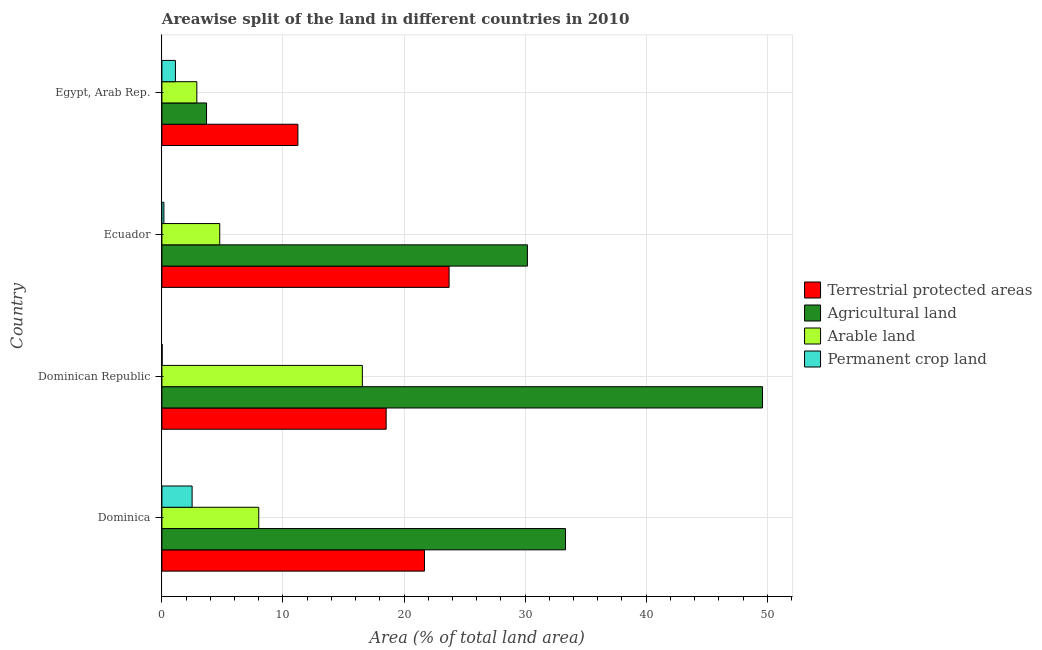Are the number of bars per tick equal to the number of legend labels?
Offer a very short reply. Yes. Are the number of bars on each tick of the Y-axis equal?
Provide a short and direct response. Yes. How many bars are there on the 1st tick from the bottom?
Your answer should be very brief. 4. What is the label of the 3rd group of bars from the top?
Provide a succinct answer. Dominican Republic. What is the percentage of area under agricultural land in Egypt, Arab Rep.?
Your answer should be very brief. 3.69. Across all countries, what is the maximum percentage of area under permanent crop land?
Give a very brief answer. 2.5. Across all countries, what is the minimum percentage of area under agricultural land?
Provide a succinct answer. 3.69. In which country was the percentage of land under terrestrial protection maximum?
Your answer should be very brief. Ecuador. In which country was the percentage of area under permanent crop land minimum?
Provide a short and direct response. Dominican Republic. What is the total percentage of area under agricultural land in the graph?
Provide a short and direct response. 116.82. What is the difference between the percentage of area under permanent crop land in Dominica and that in Egypt, Arab Rep.?
Your answer should be compact. 1.38. What is the difference between the percentage of area under permanent crop land in Dominican Republic and the percentage of area under agricultural land in Egypt, Arab Rep.?
Give a very brief answer. -3.67. What is the average percentage of area under arable land per country?
Give a very brief answer. 8.05. What is the difference between the percentage of land under terrestrial protection and percentage of area under agricultural land in Dominican Republic?
Your answer should be compact. -31.08. In how many countries, is the percentage of area under agricultural land greater than 42 %?
Offer a very short reply. 1. What is the ratio of the percentage of land under terrestrial protection in Dominica to that in Dominican Republic?
Keep it short and to the point. 1.17. Is the difference between the percentage of area under permanent crop land in Dominica and Ecuador greater than the difference between the percentage of area under agricultural land in Dominica and Ecuador?
Ensure brevity in your answer.  No. What is the difference between the highest and the second highest percentage of area under agricultural land?
Provide a short and direct response. 16.27. What is the difference between the highest and the lowest percentage of area under arable land?
Provide a succinct answer. 13.67. Is the sum of the percentage of area under permanent crop land in Dominican Republic and Egypt, Arab Rep. greater than the maximum percentage of area under agricultural land across all countries?
Offer a very short reply. No. What does the 3rd bar from the top in Dominica represents?
Offer a very short reply. Agricultural land. What does the 1st bar from the bottom in Egypt, Arab Rep. represents?
Your response must be concise. Terrestrial protected areas. Are all the bars in the graph horizontal?
Make the answer very short. Yes. Does the graph contain any zero values?
Keep it short and to the point. No. Where does the legend appear in the graph?
Make the answer very short. Center right. How many legend labels are there?
Your response must be concise. 4. What is the title of the graph?
Ensure brevity in your answer.  Areawise split of the land in different countries in 2010. What is the label or title of the X-axis?
Provide a succinct answer. Area (% of total land area). What is the Area (% of total land area) in Terrestrial protected areas in Dominica?
Keep it short and to the point. 21.69. What is the Area (% of total land area) in Agricultural land in Dominica?
Ensure brevity in your answer.  33.33. What is the Area (% of total land area) in Permanent crop land in Dominica?
Provide a short and direct response. 2.5. What is the Area (% of total land area) in Terrestrial protected areas in Dominican Republic?
Make the answer very short. 18.52. What is the Area (% of total land area) of Agricultural land in Dominican Republic?
Your answer should be compact. 49.61. What is the Area (% of total land area) in Arable land in Dominican Republic?
Offer a very short reply. 16.56. What is the Area (% of total land area) of Permanent crop land in Dominican Republic?
Offer a terse response. 0.02. What is the Area (% of total land area) in Terrestrial protected areas in Ecuador?
Ensure brevity in your answer.  23.72. What is the Area (% of total land area) of Agricultural land in Ecuador?
Your answer should be very brief. 30.19. What is the Area (% of total land area) in Arable land in Ecuador?
Your answer should be compact. 4.78. What is the Area (% of total land area) in Permanent crop land in Ecuador?
Your answer should be very brief. 0.17. What is the Area (% of total land area) in Terrestrial protected areas in Egypt, Arab Rep.?
Provide a short and direct response. 11.23. What is the Area (% of total land area) in Agricultural land in Egypt, Arab Rep.?
Your response must be concise. 3.69. What is the Area (% of total land area) in Arable land in Egypt, Arab Rep.?
Your response must be concise. 2.89. What is the Area (% of total land area) of Permanent crop land in Egypt, Arab Rep.?
Provide a short and direct response. 1.12. Across all countries, what is the maximum Area (% of total land area) in Terrestrial protected areas?
Offer a very short reply. 23.72. Across all countries, what is the maximum Area (% of total land area) of Agricultural land?
Your response must be concise. 49.61. Across all countries, what is the maximum Area (% of total land area) of Arable land?
Keep it short and to the point. 16.56. Across all countries, what is the maximum Area (% of total land area) of Permanent crop land?
Your response must be concise. 2.5. Across all countries, what is the minimum Area (% of total land area) of Terrestrial protected areas?
Give a very brief answer. 11.23. Across all countries, what is the minimum Area (% of total land area) in Agricultural land?
Keep it short and to the point. 3.69. Across all countries, what is the minimum Area (% of total land area) in Arable land?
Keep it short and to the point. 2.89. Across all countries, what is the minimum Area (% of total land area) in Permanent crop land?
Your answer should be very brief. 0.02. What is the total Area (% of total land area) of Terrestrial protected areas in the graph?
Your answer should be compact. 75.16. What is the total Area (% of total land area) of Agricultural land in the graph?
Your answer should be compact. 116.82. What is the total Area (% of total land area) of Arable land in the graph?
Your answer should be compact. 32.22. What is the total Area (% of total land area) in Permanent crop land in the graph?
Your answer should be compact. 3.8. What is the difference between the Area (% of total land area) in Terrestrial protected areas in Dominica and that in Dominican Republic?
Make the answer very short. 3.16. What is the difference between the Area (% of total land area) of Agricultural land in Dominica and that in Dominican Republic?
Offer a very short reply. -16.27. What is the difference between the Area (% of total land area) of Arable land in Dominica and that in Dominican Republic?
Ensure brevity in your answer.  -8.56. What is the difference between the Area (% of total land area) of Permanent crop land in Dominica and that in Dominican Republic?
Provide a succinct answer. 2.48. What is the difference between the Area (% of total land area) of Terrestrial protected areas in Dominica and that in Ecuador?
Your answer should be very brief. -2.03. What is the difference between the Area (% of total land area) of Agricultural land in Dominica and that in Ecuador?
Your response must be concise. 3.14. What is the difference between the Area (% of total land area) of Arable land in Dominica and that in Ecuador?
Provide a succinct answer. 3.22. What is the difference between the Area (% of total land area) of Permanent crop land in Dominica and that in Ecuador?
Offer a terse response. 2.33. What is the difference between the Area (% of total land area) in Terrestrial protected areas in Dominica and that in Egypt, Arab Rep.?
Ensure brevity in your answer.  10.46. What is the difference between the Area (% of total land area) of Agricultural land in Dominica and that in Egypt, Arab Rep.?
Your answer should be very brief. 29.65. What is the difference between the Area (% of total land area) of Arable land in Dominica and that in Egypt, Arab Rep.?
Make the answer very short. 5.11. What is the difference between the Area (% of total land area) of Permanent crop land in Dominica and that in Egypt, Arab Rep.?
Keep it short and to the point. 1.38. What is the difference between the Area (% of total land area) in Terrestrial protected areas in Dominican Republic and that in Ecuador?
Keep it short and to the point. -5.2. What is the difference between the Area (% of total land area) in Agricultural land in Dominican Republic and that in Ecuador?
Provide a short and direct response. 19.42. What is the difference between the Area (% of total land area) of Arable land in Dominican Republic and that in Ecuador?
Ensure brevity in your answer.  11.78. What is the difference between the Area (% of total land area) of Permanent crop land in Dominican Republic and that in Ecuador?
Offer a terse response. -0.15. What is the difference between the Area (% of total land area) of Terrestrial protected areas in Dominican Republic and that in Egypt, Arab Rep.?
Keep it short and to the point. 7.29. What is the difference between the Area (% of total land area) in Agricultural land in Dominican Republic and that in Egypt, Arab Rep.?
Make the answer very short. 45.92. What is the difference between the Area (% of total land area) of Arable land in Dominican Republic and that in Egypt, Arab Rep.?
Offer a very short reply. 13.67. What is the difference between the Area (% of total land area) of Permanent crop land in Dominican Republic and that in Egypt, Arab Rep.?
Provide a succinct answer. -1.1. What is the difference between the Area (% of total land area) of Terrestrial protected areas in Ecuador and that in Egypt, Arab Rep.?
Provide a short and direct response. 12.49. What is the difference between the Area (% of total land area) of Agricultural land in Ecuador and that in Egypt, Arab Rep.?
Your answer should be compact. 26.5. What is the difference between the Area (% of total land area) in Arable land in Ecuador and that in Egypt, Arab Rep.?
Your response must be concise. 1.89. What is the difference between the Area (% of total land area) in Permanent crop land in Ecuador and that in Egypt, Arab Rep.?
Offer a very short reply. -0.95. What is the difference between the Area (% of total land area) in Terrestrial protected areas in Dominica and the Area (% of total land area) in Agricultural land in Dominican Republic?
Your response must be concise. -27.92. What is the difference between the Area (% of total land area) in Terrestrial protected areas in Dominica and the Area (% of total land area) in Arable land in Dominican Republic?
Provide a short and direct response. 5.13. What is the difference between the Area (% of total land area) in Terrestrial protected areas in Dominica and the Area (% of total land area) in Permanent crop land in Dominican Republic?
Your answer should be very brief. 21.67. What is the difference between the Area (% of total land area) of Agricultural land in Dominica and the Area (% of total land area) of Arable land in Dominican Republic?
Make the answer very short. 16.78. What is the difference between the Area (% of total land area) of Agricultural land in Dominica and the Area (% of total land area) of Permanent crop land in Dominican Republic?
Offer a very short reply. 33.31. What is the difference between the Area (% of total land area) of Arable land in Dominica and the Area (% of total land area) of Permanent crop land in Dominican Republic?
Provide a succinct answer. 7.98. What is the difference between the Area (% of total land area) in Terrestrial protected areas in Dominica and the Area (% of total land area) in Agricultural land in Ecuador?
Make the answer very short. -8.5. What is the difference between the Area (% of total land area) of Terrestrial protected areas in Dominica and the Area (% of total land area) of Arable land in Ecuador?
Ensure brevity in your answer.  16.91. What is the difference between the Area (% of total land area) in Terrestrial protected areas in Dominica and the Area (% of total land area) in Permanent crop land in Ecuador?
Provide a short and direct response. 21.52. What is the difference between the Area (% of total land area) of Agricultural land in Dominica and the Area (% of total land area) of Arable land in Ecuador?
Your answer should be very brief. 28.56. What is the difference between the Area (% of total land area) in Agricultural land in Dominica and the Area (% of total land area) in Permanent crop land in Ecuador?
Offer a very short reply. 33.17. What is the difference between the Area (% of total land area) of Arable land in Dominica and the Area (% of total land area) of Permanent crop land in Ecuador?
Ensure brevity in your answer.  7.83. What is the difference between the Area (% of total land area) in Terrestrial protected areas in Dominica and the Area (% of total land area) in Agricultural land in Egypt, Arab Rep.?
Provide a short and direct response. 18. What is the difference between the Area (% of total land area) of Terrestrial protected areas in Dominica and the Area (% of total land area) of Arable land in Egypt, Arab Rep.?
Provide a short and direct response. 18.8. What is the difference between the Area (% of total land area) in Terrestrial protected areas in Dominica and the Area (% of total land area) in Permanent crop land in Egypt, Arab Rep.?
Ensure brevity in your answer.  20.57. What is the difference between the Area (% of total land area) in Agricultural land in Dominica and the Area (% of total land area) in Arable land in Egypt, Arab Rep.?
Your answer should be compact. 30.45. What is the difference between the Area (% of total land area) in Agricultural land in Dominica and the Area (% of total land area) in Permanent crop land in Egypt, Arab Rep.?
Give a very brief answer. 32.22. What is the difference between the Area (% of total land area) of Arable land in Dominica and the Area (% of total land area) of Permanent crop land in Egypt, Arab Rep.?
Keep it short and to the point. 6.88. What is the difference between the Area (% of total land area) of Terrestrial protected areas in Dominican Republic and the Area (% of total land area) of Agricultural land in Ecuador?
Give a very brief answer. -11.67. What is the difference between the Area (% of total land area) in Terrestrial protected areas in Dominican Republic and the Area (% of total land area) in Arable land in Ecuador?
Make the answer very short. 13.75. What is the difference between the Area (% of total land area) of Terrestrial protected areas in Dominican Republic and the Area (% of total land area) of Permanent crop land in Ecuador?
Your response must be concise. 18.36. What is the difference between the Area (% of total land area) in Agricultural land in Dominican Republic and the Area (% of total land area) in Arable land in Ecuador?
Your answer should be compact. 44.83. What is the difference between the Area (% of total land area) of Agricultural land in Dominican Republic and the Area (% of total land area) of Permanent crop land in Ecuador?
Keep it short and to the point. 49.44. What is the difference between the Area (% of total land area) in Arable land in Dominican Republic and the Area (% of total land area) in Permanent crop land in Ecuador?
Provide a succinct answer. 16.39. What is the difference between the Area (% of total land area) of Terrestrial protected areas in Dominican Republic and the Area (% of total land area) of Agricultural land in Egypt, Arab Rep.?
Offer a very short reply. 14.84. What is the difference between the Area (% of total land area) in Terrestrial protected areas in Dominican Republic and the Area (% of total land area) in Arable land in Egypt, Arab Rep.?
Your response must be concise. 15.64. What is the difference between the Area (% of total land area) in Terrestrial protected areas in Dominican Republic and the Area (% of total land area) in Permanent crop land in Egypt, Arab Rep.?
Your answer should be very brief. 17.4. What is the difference between the Area (% of total land area) of Agricultural land in Dominican Republic and the Area (% of total land area) of Arable land in Egypt, Arab Rep.?
Provide a short and direct response. 46.72. What is the difference between the Area (% of total land area) in Agricultural land in Dominican Republic and the Area (% of total land area) in Permanent crop land in Egypt, Arab Rep.?
Make the answer very short. 48.49. What is the difference between the Area (% of total land area) of Arable land in Dominican Republic and the Area (% of total land area) of Permanent crop land in Egypt, Arab Rep.?
Provide a short and direct response. 15.44. What is the difference between the Area (% of total land area) in Terrestrial protected areas in Ecuador and the Area (% of total land area) in Agricultural land in Egypt, Arab Rep.?
Your answer should be very brief. 20.03. What is the difference between the Area (% of total land area) in Terrestrial protected areas in Ecuador and the Area (% of total land area) in Arable land in Egypt, Arab Rep.?
Keep it short and to the point. 20.83. What is the difference between the Area (% of total land area) of Terrestrial protected areas in Ecuador and the Area (% of total land area) of Permanent crop land in Egypt, Arab Rep.?
Offer a very short reply. 22.6. What is the difference between the Area (% of total land area) in Agricultural land in Ecuador and the Area (% of total land area) in Arable land in Egypt, Arab Rep.?
Provide a short and direct response. 27.3. What is the difference between the Area (% of total land area) in Agricultural land in Ecuador and the Area (% of total land area) in Permanent crop land in Egypt, Arab Rep.?
Ensure brevity in your answer.  29.07. What is the difference between the Area (% of total land area) in Arable land in Ecuador and the Area (% of total land area) in Permanent crop land in Egypt, Arab Rep.?
Offer a terse response. 3.66. What is the average Area (% of total land area) in Terrestrial protected areas per country?
Offer a terse response. 18.79. What is the average Area (% of total land area) of Agricultural land per country?
Offer a terse response. 29.2. What is the average Area (% of total land area) of Arable land per country?
Make the answer very short. 8.05. What is the average Area (% of total land area) in Permanent crop land per country?
Make the answer very short. 0.95. What is the difference between the Area (% of total land area) in Terrestrial protected areas and Area (% of total land area) in Agricultural land in Dominica?
Offer a very short reply. -11.65. What is the difference between the Area (% of total land area) in Terrestrial protected areas and Area (% of total land area) in Arable land in Dominica?
Your answer should be very brief. 13.69. What is the difference between the Area (% of total land area) in Terrestrial protected areas and Area (% of total land area) in Permanent crop land in Dominica?
Offer a terse response. 19.19. What is the difference between the Area (% of total land area) in Agricultural land and Area (% of total land area) in Arable land in Dominica?
Provide a short and direct response. 25.33. What is the difference between the Area (% of total land area) of Agricultural land and Area (% of total land area) of Permanent crop land in Dominica?
Offer a terse response. 30.84. What is the difference between the Area (% of total land area) of Arable land and Area (% of total land area) of Permanent crop land in Dominica?
Make the answer very short. 5.5. What is the difference between the Area (% of total land area) of Terrestrial protected areas and Area (% of total land area) of Agricultural land in Dominican Republic?
Offer a very short reply. -31.08. What is the difference between the Area (% of total land area) in Terrestrial protected areas and Area (% of total land area) in Arable land in Dominican Republic?
Your answer should be compact. 1.97. What is the difference between the Area (% of total land area) of Terrestrial protected areas and Area (% of total land area) of Permanent crop land in Dominican Republic?
Your answer should be compact. 18.5. What is the difference between the Area (% of total land area) of Agricultural land and Area (% of total land area) of Arable land in Dominican Republic?
Offer a very short reply. 33.05. What is the difference between the Area (% of total land area) of Agricultural land and Area (% of total land area) of Permanent crop land in Dominican Republic?
Offer a very short reply. 49.59. What is the difference between the Area (% of total land area) of Arable land and Area (% of total land area) of Permanent crop land in Dominican Republic?
Your answer should be compact. 16.54. What is the difference between the Area (% of total land area) of Terrestrial protected areas and Area (% of total land area) of Agricultural land in Ecuador?
Offer a terse response. -6.47. What is the difference between the Area (% of total land area) of Terrestrial protected areas and Area (% of total land area) of Arable land in Ecuador?
Provide a succinct answer. 18.94. What is the difference between the Area (% of total land area) of Terrestrial protected areas and Area (% of total land area) of Permanent crop land in Ecuador?
Keep it short and to the point. 23.56. What is the difference between the Area (% of total land area) in Agricultural land and Area (% of total land area) in Arable land in Ecuador?
Keep it short and to the point. 25.41. What is the difference between the Area (% of total land area) in Agricultural land and Area (% of total land area) in Permanent crop land in Ecuador?
Provide a short and direct response. 30.02. What is the difference between the Area (% of total land area) of Arable land and Area (% of total land area) of Permanent crop land in Ecuador?
Provide a succinct answer. 4.61. What is the difference between the Area (% of total land area) in Terrestrial protected areas and Area (% of total land area) in Agricultural land in Egypt, Arab Rep.?
Provide a short and direct response. 7.54. What is the difference between the Area (% of total land area) in Terrestrial protected areas and Area (% of total land area) in Arable land in Egypt, Arab Rep.?
Offer a very short reply. 8.35. What is the difference between the Area (% of total land area) of Terrestrial protected areas and Area (% of total land area) of Permanent crop land in Egypt, Arab Rep.?
Make the answer very short. 10.11. What is the difference between the Area (% of total land area) of Agricultural land and Area (% of total land area) of Arable land in Egypt, Arab Rep.?
Your answer should be very brief. 0.8. What is the difference between the Area (% of total land area) in Agricultural land and Area (% of total land area) in Permanent crop land in Egypt, Arab Rep.?
Provide a short and direct response. 2.57. What is the difference between the Area (% of total land area) of Arable land and Area (% of total land area) of Permanent crop land in Egypt, Arab Rep.?
Provide a short and direct response. 1.77. What is the ratio of the Area (% of total land area) of Terrestrial protected areas in Dominica to that in Dominican Republic?
Your response must be concise. 1.17. What is the ratio of the Area (% of total land area) of Agricultural land in Dominica to that in Dominican Republic?
Make the answer very short. 0.67. What is the ratio of the Area (% of total land area) in Arable land in Dominica to that in Dominican Republic?
Offer a very short reply. 0.48. What is the ratio of the Area (% of total land area) of Permanent crop land in Dominica to that in Dominican Republic?
Give a very brief answer. 126.03. What is the ratio of the Area (% of total land area) of Terrestrial protected areas in Dominica to that in Ecuador?
Provide a succinct answer. 0.91. What is the ratio of the Area (% of total land area) in Agricultural land in Dominica to that in Ecuador?
Give a very brief answer. 1.1. What is the ratio of the Area (% of total land area) of Arable land in Dominica to that in Ecuador?
Your answer should be very brief. 1.67. What is the ratio of the Area (% of total land area) of Permanent crop land in Dominica to that in Ecuador?
Your answer should be very brief. 15.11. What is the ratio of the Area (% of total land area) of Terrestrial protected areas in Dominica to that in Egypt, Arab Rep.?
Ensure brevity in your answer.  1.93. What is the ratio of the Area (% of total land area) of Agricultural land in Dominica to that in Egypt, Arab Rep.?
Give a very brief answer. 9.04. What is the ratio of the Area (% of total land area) of Arable land in Dominica to that in Egypt, Arab Rep.?
Make the answer very short. 2.77. What is the ratio of the Area (% of total land area) of Permanent crop land in Dominica to that in Egypt, Arab Rep.?
Your answer should be very brief. 2.23. What is the ratio of the Area (% of total land area) in Terrestrial protected areas in Dominican Republic to that in Ecuador?
Your answer should be very brief. 0.78. What is the ratio of the Area (% of total land area) in Agricultural land in Dominican Republic to that in Ecuador?
Make the answer very short. 1.64. What is the ratio of the Area (% of total land area) in Arable land in Dominican Republic to that in Ecuador?
Give a very brief answer. 3.47. What is the ratio of the Area (% of total land area) of Permanent crop land in Dominican Republic to that in Ecuador?
Your answer should be very brief. 0.12. What is the ratio of the Area (% of total land area) in Terrestrial protected areas in Dominican Republic to that in Egypt, Arab Rep.?
Your answer should be compact. 1.65. What is the ratio of the Area (% of total land area) in Agricultural land in Dominican Republic to that in Egypt, Arab Rep.?
Your response must be concise. 13.45. What is the ratio of the Area (% of total land area) in Arable land in Dominican Republic to that in Egypt, Arab Rep.?
Offer a terse response. 5.74. What is the ratio of the Area (% of total land area) in Permanent crop land in Dominican Republic to that in Egypt, Arab Rep.?
Provide a succinct answer. 0.02. What is the ratio of the Area (% of total land area) of Terrestrial protected areas in Ecuador to that in Egypt, Arab Rep.?
Offer a terse response. 2.11. What is the ratio of the Area (% of total land area) in Agricultural land in Ecuador to that in Egypt, Arab Rep.?
Your answer should be very brief. 8.19. What is the ratio of the Area (% of total land area) in Arable land in Ecuador to that in Egypt, Arab Rep.?
Provide a short and direct response. 1.66. What is the ratio of the Area (% of total land area) of Permanent crop land in Ecuador to that in Egypt, Arab Rep.?
Your answer should be very brief. 0.15. What is the difference between the highest and the second highest Area (% of total land area) of Terrestrial protected areas?
Ensure brevity in your answer.  2.03. What is the difference between the highest and the second highest Area (% of total land area) of Agricultural land?
Keep it short and to the point. 16.27. What is the difference between the highest and the second highest Area (% of total land area) of Arable land?
Provide a succinct answer. 8.56. What is the difference between the highest and the second highest Area (% of total land area) of Permanent crop land?
Your answer should be very brief. 1.38. What is the difference between the highest and the lowest Area (% of total land area) in Terrestrial protected areas?
Provide a short and direct response. 12.49. What is the difference between the highest and the lowest Area (% of total land area) in Agricultural land?
Offer a terse response. 45.92. What is the difference between the highest and the lowest Area (% of total land area) in Arable land?
Make the answer very short. 13.67. What is the difference between the highest and the lowest Area (% of total land area) in Permanent crop land?
Provide a succinct answer. 2.48. 